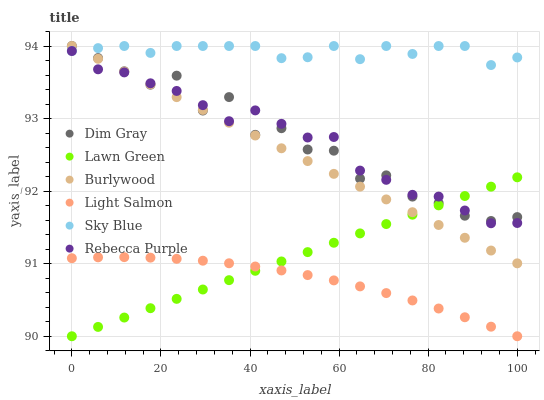Does Light Salmon have the minimum area under the curve?
Answer yes or no. Yes. Does Sky Blue have the maximum area under the curve?
Answer yes or no. Yes. Does Dim Gray have the minimum area under the curve?
Answer yes or no. No. Does Dim Gray have the maximum area under the curve?
Answer yes or no. No. Is Burlywood the smoothest?
Answer yes or no. Yes. Is Dim Gray the roughest?
Answer yes or no. Yes. Is Light Salmon the smoothest?
Answer yes or no. No. Is Light Salmon the roughest?
Answer yes or no. No. Does Lawn Green have the lowest value?
Answer yes or no. Yes. Does Dim Gray have the lowest value?
Answer yes or no. No. Does Sky Blue have the highest value?
Answer yes or no. Yes. Does Light Salmon have the highest value?
Answer yes or no. No. Is Rebecca Purple less than Sky Blue?
Answer yes or no. Yes. Is Rebecca Purple greater than Light Salmon?
Answer yes or no. Yes. Does Dim Gray intersect Rebecca Purple?
Answer yes or no. Yes. Is Dim Gray less than Rebecca Purple?
Answer yes or no. No. Is Dim Gray greater than Rebecca Purple?
Answer yes or no. No. Does Rebecca Purple intersect Sky Blue?
Answer yes or no. No. 